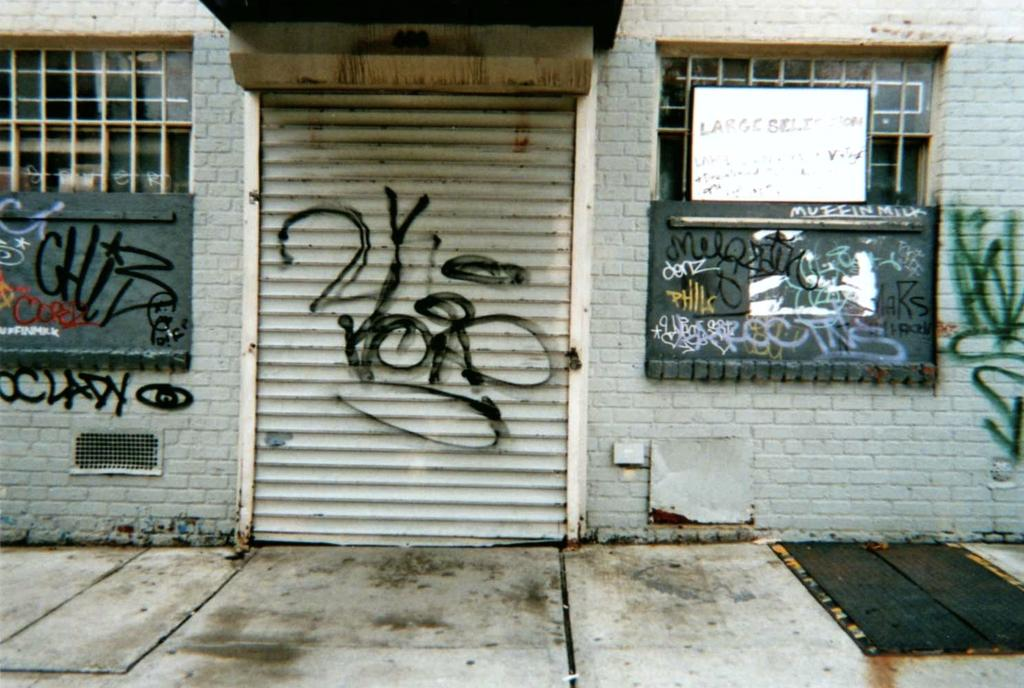What type of structure is visible in the image? There is a wall with shutters in the image. What can be seen on the boards in the image? There are boards with text and painting in the image. What is visible below the wall in the image? The ground is visible in front of the wall. What material is present at the top of the image? There is wood at the top of the image. How does the bomb affect the wall in the image? There is no bomb present in the image, so it cannot affect the wall. 